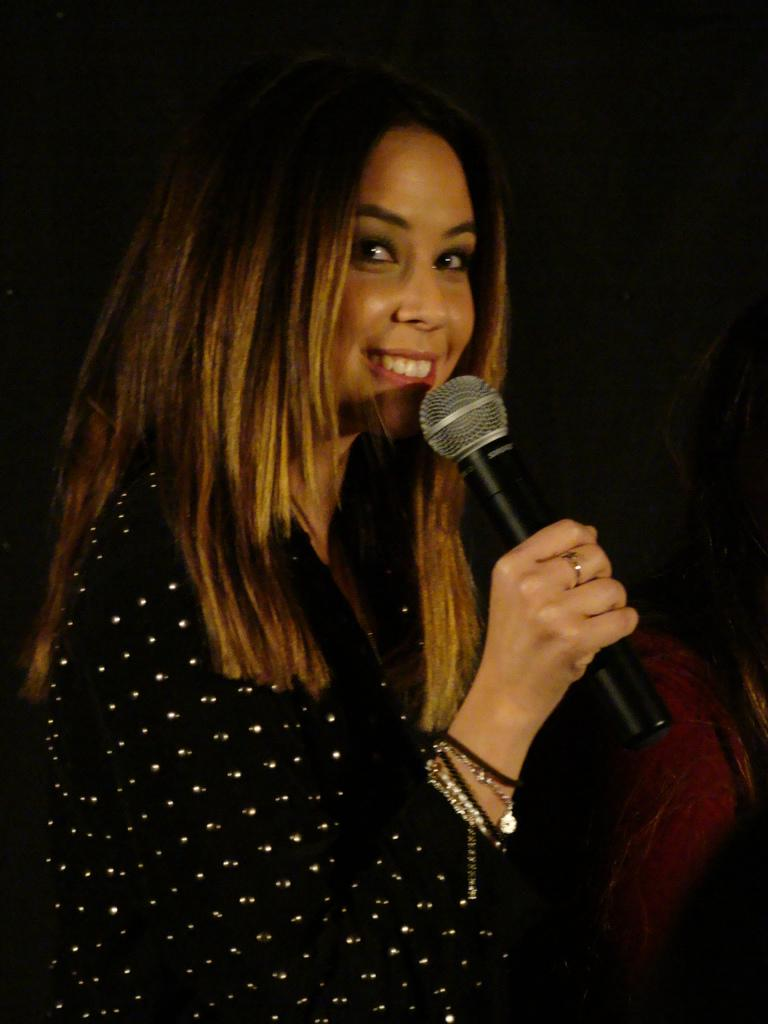Who is the main subject in the image? There is a woman in the image. What is the woman wearing on her wrist? The woman is wearing a bracelet. What is the woman holding in her hand? The woman is holding a mic with her hand. What is the woman's facial expression in the image? The woman is smiling. How would you describe the background of the image? The background of the image is dark. What type of brush can be seen in the woman's hair in the image? There is no brush visible in the woman's hair in the image. What kind of root is growing near the woman in the image? There is no root present in the image; it features a woman holding a mic with a dark background. 